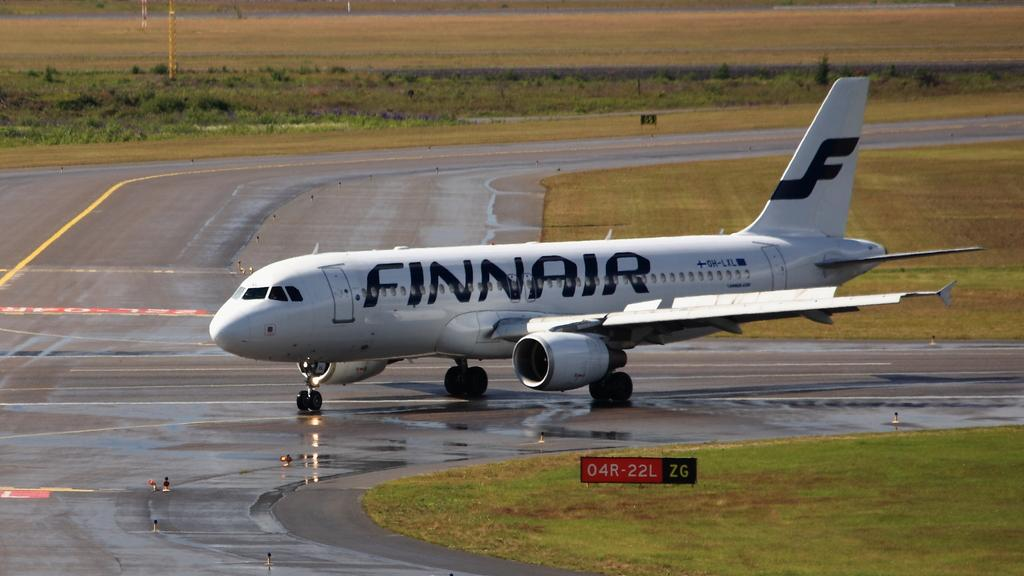<image>
Create a compact narrative representing the image presented. A Finnair plane makes a turn on a runway. 